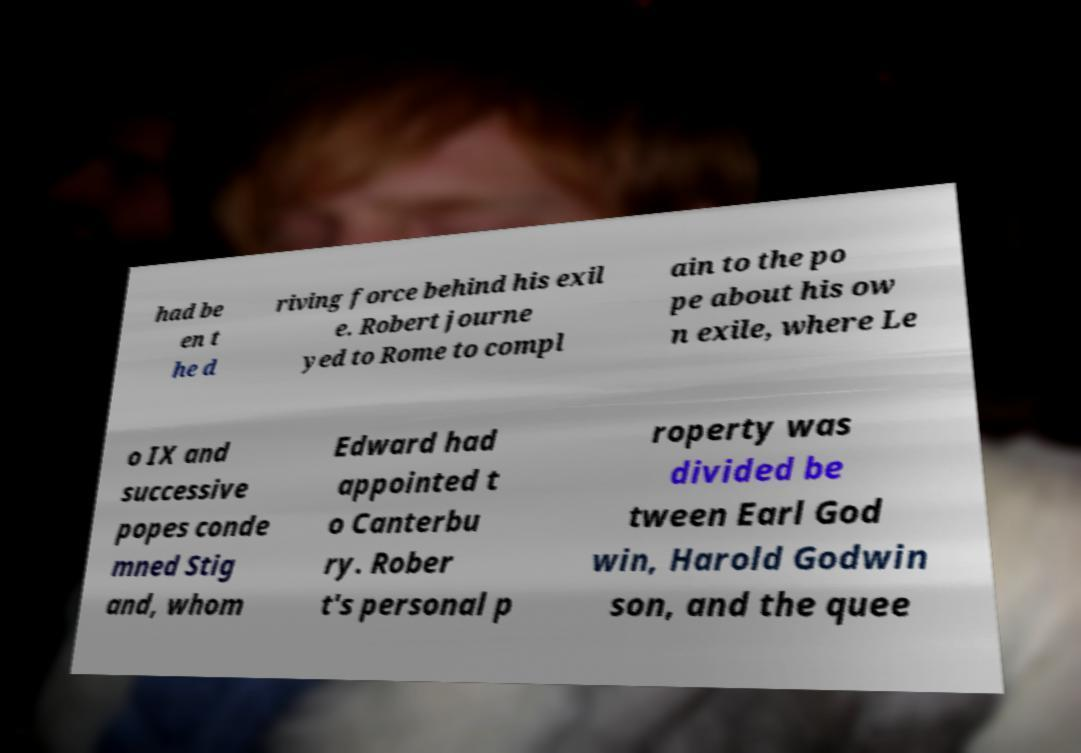Can you read and provide the text displayed in the image?This photo seems to have some interesting text. Can you extract and type it out for me? had be en t he d riving force behind his exil e. Robert journe yed to Rome to compl ain to the po pe about his ow n exile, where Le o IX and successive popes conde mned Stig and, whom Edward had appointed t o Canterbu ry. Rober t's personal p roperty was divided be tween Earl God win, Harold Godwin son, and the quee 